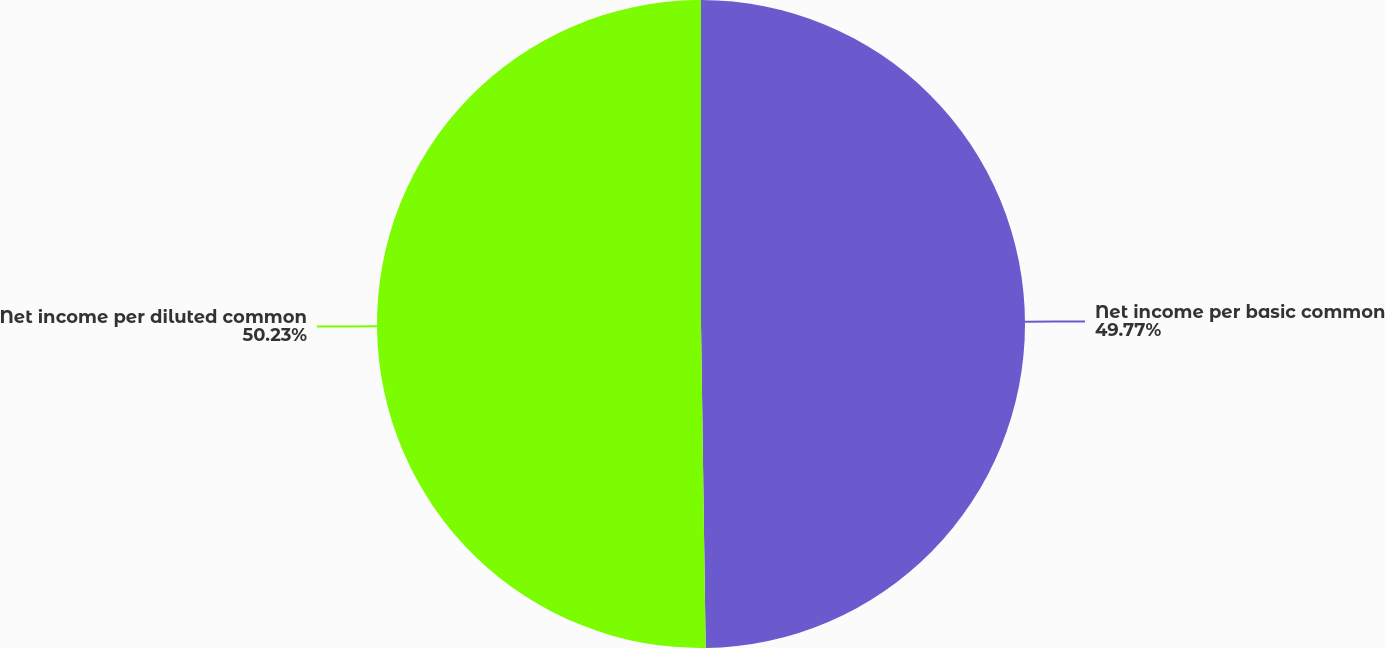Convert chart. <chart><loc_0><loc_0><loc_500><loc_500><pie_chart><fcel>Net income per basic common<fcel>Net income per diluted common<nl><fcel>49.77%<fcel>50.23%<nl></chart> 